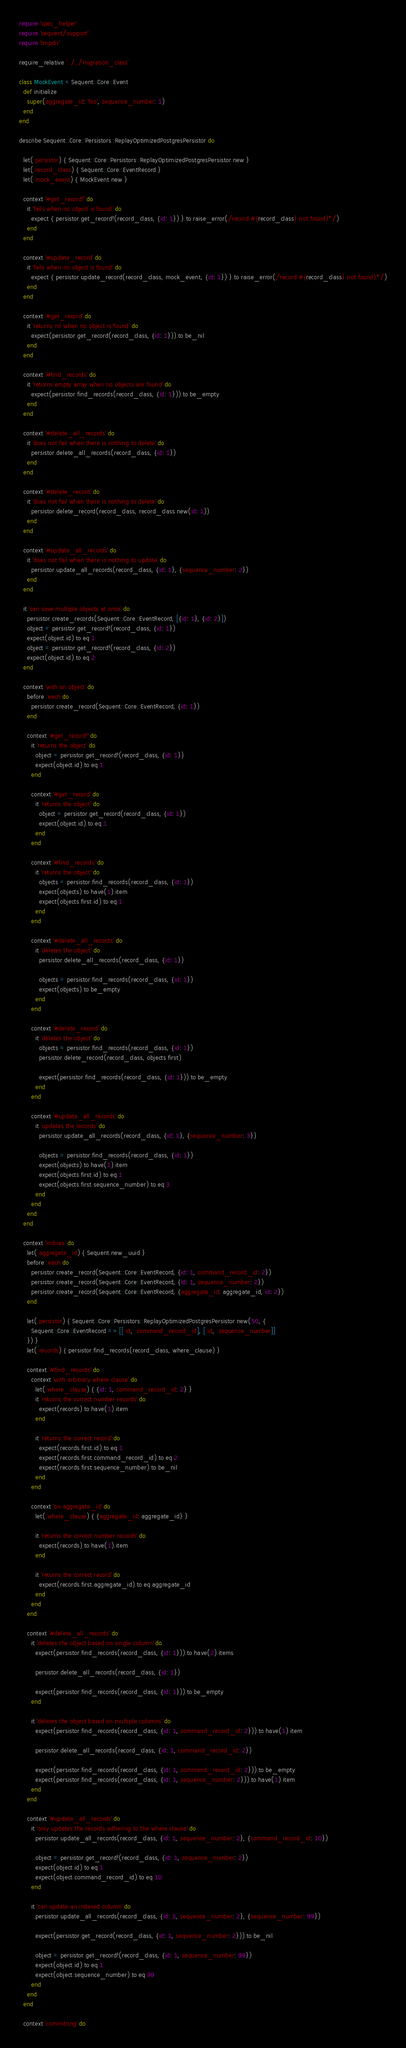<code> <loc_0><loc_0><loc_500><loc_500><_Ruby_>require 'spec_helper'
require 'sequent/support'
require 'tmpdir'

require_relative '../../migration_class'

class MockEvent < Sequent::Core::Event
  def initialize
    super(aggregate_id: 'foo', sequence_number: 1)
  end
end

describe Sequent::Core::Persistors::ReplayOptimizedPostgresPersistor do

  let(:persistor) { Sequent::Core::Persistors::ReplayOptimizedPostgresPersistor.new }
  let(:record_class) { Sequent::Core::EventRecord }
  let(:mock_event) { MockEvent.new }

  context '#get_record!' do
    it 'fails when no object is found' do
      expect { persistor.get_record!(record_class, {id: 1}) }.to raise_error(/record #{record_class} not found}*/)
    end
  end

  context '#update_record' do
    it 'fails when no object is found' do
      expect { persistor.update_record(record_class, mock_event, {id: 1}) }.to raise_error(/record #{record_class} not found}*/)
    end
  end

  context '#get_record' do
    it 'returns nil when no object is found' do
      expect(persistor.get_record(record_class, {id: 1})).to be_nil
    end
  end

  context '#find_records' do
    it 'returns empty array when no objects are found' do
      expect(persistor.find_records(record_class, {id: 1})).to be_empty
    end
  end

  context '#delete_all_records' do
    it 'does not fail when there is nothing to delete' do
      persistor.delete_all_records(record_class, {id: 1})
    end
  end

  context '#delete_record' do
    it 'does not fail when there is nothing to delete' do
      persistor.delete_record(record_class, record_class.new(id: 1))
    end
  end

  context '#update_all_records' do
    it 'does not fail when there is nothing to update' do
      persistor.update_all_records(record_class, {id: 1}, {sequence_number: 2})
    end
  end

  it 'can save multiple objects at once' do
    persistor.create_records(Sequent::Core::EventRecord, [{id: 1}, {id: 2}])
    object = persistor.get_record!(record_class, {id: 1})
    expect(object.id).to eq 1
    object = persistor.get_record!(record_class, {id: 2})
    expect(object.id).to eq 2
  end

  context 'with an object' do
    before :each do
      persistor.create_record(Sequent::Core::EventRecord, {id: 1})
    end

    context '#get_record!' do
      it 'returns the object' do
        object = persistor.get_record!(record_class, {id: 1})
        expect(object.id).to eq 1
      end

      context '#get_record' do
        it 'returns the object' do
          object = persistor.get_record(record_class, {id: 1})
          expect(object.id).to eq 1
        end
      end

      context '#find_records' do
        it 'returns the object' do
          objects = persistor.find_records(record_class, {id: 1})
          expect(objects).to have(1).item
          expect(objects.first.id).to eq 1
        end
      end

      context '#delete_all_records' do
        it 'deletes the object' do
          persistor.delete_all_records(record_class, {id: 1})

          objects = persistor.find_records(record_class, {id: 1})
          expect(objects).to be_empty
        end
      end

      context '#delete_record' do
        it 'deletes the object' do
          objects = persistor.find_records(record_class, {id: 1})
          persistor.delete_record(record_class, objects.first)

          expect(persistor.find_records(record_class, {id: 1})).to be_empty
        end
      end

      context '#update_all_records' do
        it 'updates the records' do
          persistor.update_all_records(record_class, {id: 1}, {sequence_number: 3})

          objects = persistor.find_records(record_class, {id: 1})
          expect(objects).to have(1).item
          expect(objects.first.id).to eq 1
          expect(objects.first.sequence_number).to eq 3
        end
      end
    end
  end

  context 'indices' do
    let(:aggregate_id) { Sequent.new_uuid }
    before :each do
      persistor.create_record(Sequent::Core::EventRecord, {id: 1, command_record_id: 2})
      persistor.create_record(Sequent::Core::EventRecord, {id: 1, sequence_number: 2})
      persistor.create_record(Sequent::Core::EventRecord, {aggregate_id: aggregate_id, id: 2})
    end

    let(:persistor) { Sequent::Core::Persistors::ReplayOptimizedPostgresPersistor.new(50, {
      Sequent::Core::EventRecord => [[:id, :command_record_id], [:id, :sequence_number]]
    }) }
    let(:records) { persistor.find_records(record_class, where_clause) }

    context '#find_records' do
      context 'with arbitrary where clause' do
        let(:where_clause) { {id: 1, command_record_id: 2} }
        it 'returns the correct number records' do
          expect(records).to have(1).item
        end

        it 'returns the correct record' do
          expect(records.first.id).to eq 1
          expect(records.first.command_record_id).to eq 2
          expect(records.first.sequence_number).to be_nil
        end
      end

      context 'on aggregate_id' do
        let(:where_clause) { {aggregate_id: aggregate_id} }

        it 'returns the correct number records' do
          expect(records).to have(1).item
        end

        it 'returns the correct record' do
          expect(records.first.aggregate_id).to eq aggregate_id
        end
      end
    end

    context '#delete_all_records' do
      it 'deletes the object based on single column' do
        expect(persistor.find_records(record_class, {id: 1})).to have(2).items

        persistor.delete_all_records(record_class, {id: 1})

        expect(persistor.find_records(record_class, {id: 1})).to be_empty
      end

      it 'deletes the object based on multiple columns' do
        expect(persistor.find_records(record_class, {id: 1, command_record_id: 2})).to have(1).item

        persistor.delete_all_records(record_class, {id: 1, command_record_id: 2})

        expect(persistor.find_records(record_class, {id: 1, command_record_id: 2})).to be_empty
        expect(persistor.find_records(record_class, {id: 1, sequence_number: 2})).to have(1).item
      end
    end

    context '#update_all_records' do
      it 'only updates the records adhering to the where clause' do
        persistor.update_all_records(record_class, {id: 1, sequence_number: 2}, {command_record_id: 10})

        object = persistor.get_record!(record_class, {id: 1, sequence_number: 2})
        expect(object.id).to eq 1
        expect(object.command_record_id).to eq 10
      end

      it 'can update an indexed column' do
        persistor.update_all_records(record_class, {id: 1, sequence_number: 2}, {sequence_number: 99})

        expect(persistor.get_record(record_class, {id: 1, sequence_number: 2})).to be_nil

        object = persistor.get_record!(record_class, {id: 1, sequence_number: 99})
        expect(object.id).to eq 1
        expect(object.sequence_number).to eq 99
      end
    end
  end

  context 'committing' do</code> 